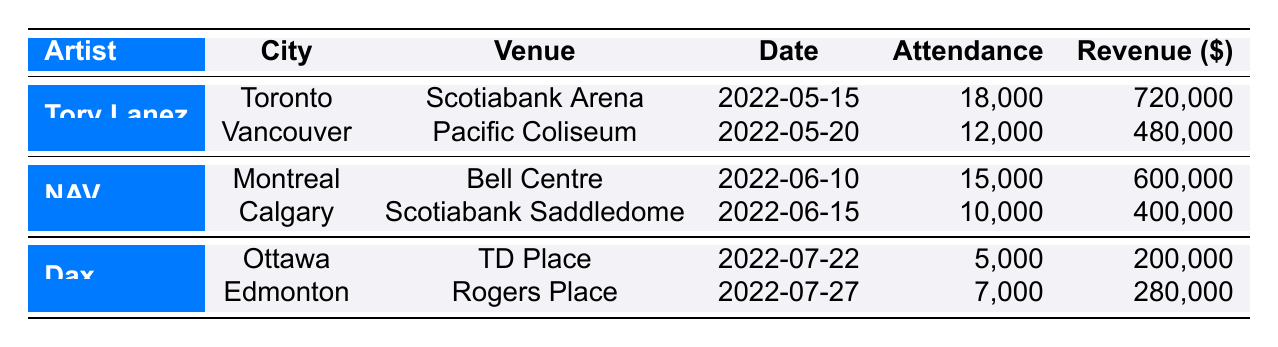What city hosted Tory Lanez's concert on May 15, 2022? The table shows Tory Lanez performed in Toronto on May 15, 2022, as mentioned under the "City" column for his concert date.
Answer: Toronto What was the total attendance for NAV's concerts in 2022? NAV performed in Montreal with an attendance of 15,000 and in Calgary with 10,000. Adding these together gives a total attendance of 15,000 + 10,000 = 25,000.
Answer: 25000 Did Dax perform in Vancouver in 2022? The table lists Dax's concerts which took place in Ottawa and Edmonton, with no mention of a concert in Vancouver.
Answer: No What was the revenue generated by the concert held at the Bell Centre? The concert at the Bell Centre was hosted by NAV, with a recorded revenue of 600,000, as noted in the corresponding row under the "Revenue" column.
Answer: 600000 Which artist had the highest single concert attendance and what was that number? Comparing the attendance for all artists, Tory Lanez in Toronto had the highest single concert attendance at 18,000, as shown in the table.
Answer: 18000 What is the average revenue per concert for Dax? Dax had two concerts with revenues of 200,000 and 280,000. To find the average, sum these revenues (200,000 + 280,000 = 480,000) and divide by the number of concerts (480,000 / 2 = 240,000).
Answer: 240000 Were any concerts held by Tory Lanez in June? Tory Lanez only held concerts in May, as there are no concerts listed for June in his section of the table.
Answer: No What date did NAV perform in Calgary? The table indicates that NAV performed in Calgary on June 15, 2022, as specified under the "Date" column for his concert.
Answer: June 15, 2022 